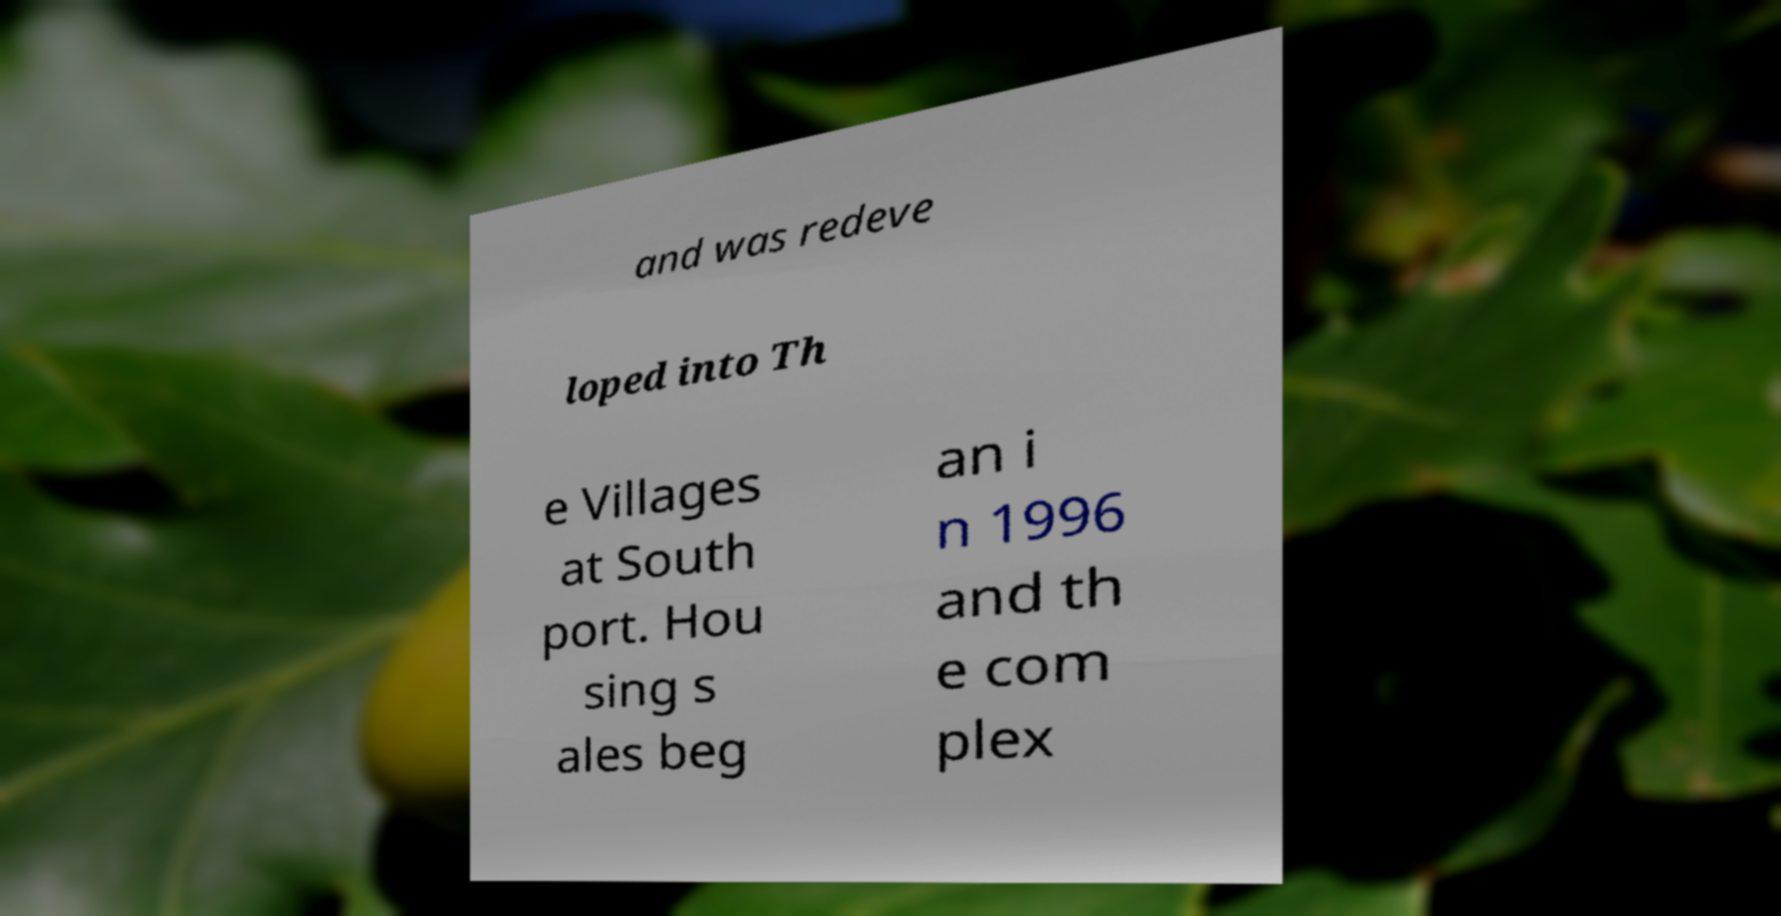Can you accurately transcribe the text from the provided image for me? and was redeve loped into Th e Villages at South port. Hou sing s ales beg an i n 1996 and th e com plex 